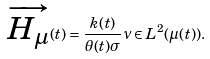<formula> <loc_0><loc_0><loc_500><loc_500>\overrightarrow { H _ { \mu } } ( t ) = \frac { k ( t ) } { \theta ( t ) \sigma } \nu \in L ^ { 2 } ( \mu ( t ) ) .</formula> 